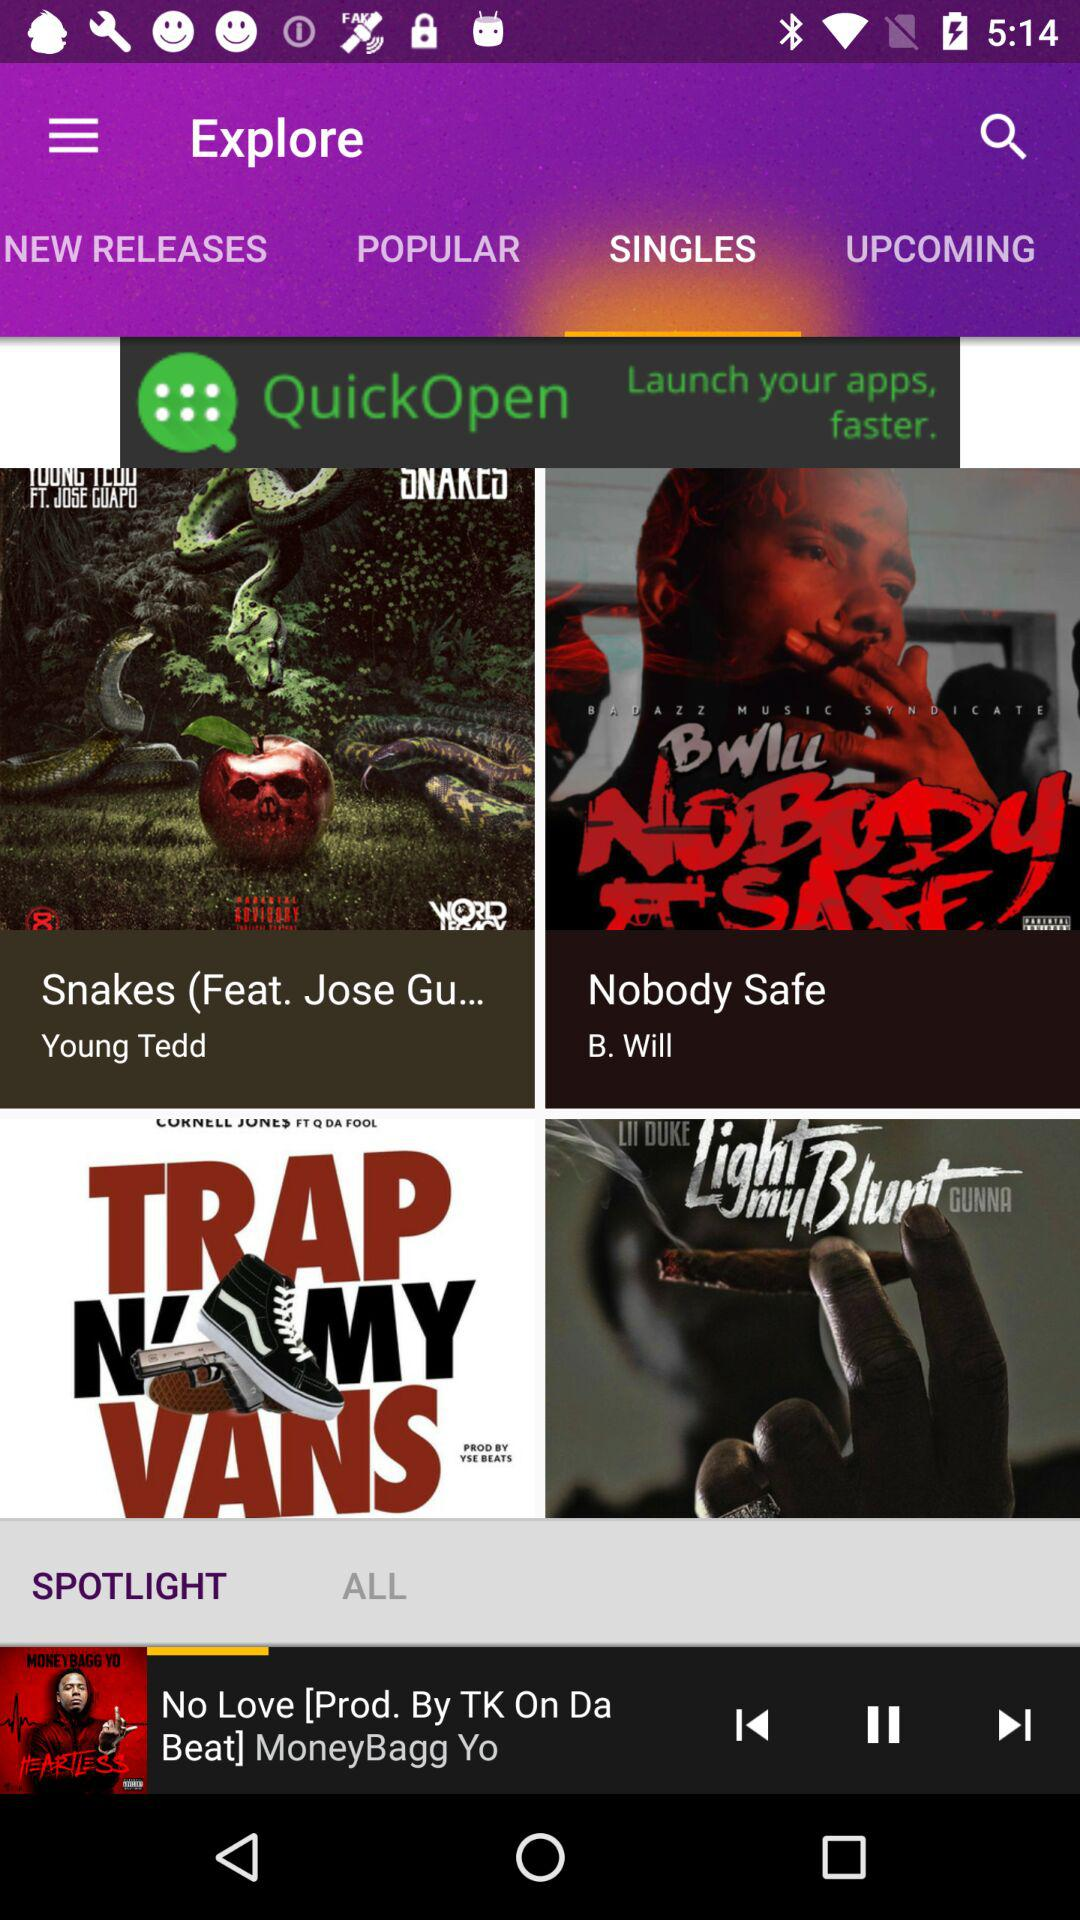What is the song name that is playing? The song name that is playing is "No Love". 